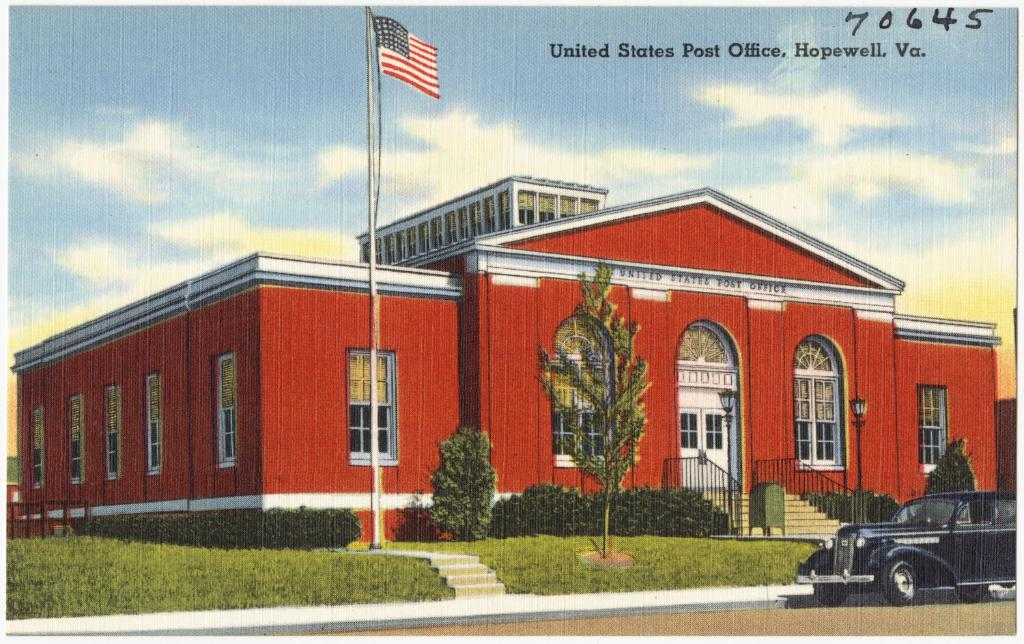What is depicted on the poster on the left side of the image? There is a poster of a black car on the left side of the image. What type of living organisms can be seen in the image? Plants are present in the image. What is the symbolic object in the image? There is a flag present in the image. What type of structure is visible in the image? There is a building in the image. What architectural features can be seen on the building? The building has a door, stairs, and windows. How does the machine fall from the building in the image? There is no machine present in the image, and therefore no such event occurs. 